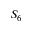Convert formula to latex. <formula><loc_0><loc_0><loc_500><loc_500>S _ { 6 }</formula> 